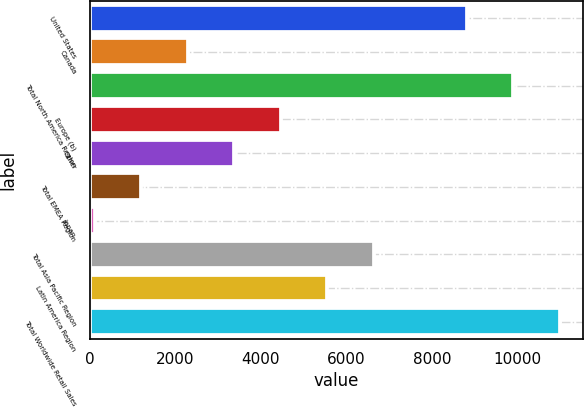<chart> <loc_0><loc_0><loc_500><loc_500><bar_chart><fcel>United States<fcel>Canada<fcel>Total North America Region<fcel>Europe (b)<fcel>Other<fcel>Total EMEA Region<fcel>Japan<fcel>Total Asia Pacific Region<fcel>Latin America Region<fcel>Total Worldwide Retail Sales<nl><fcel>8813.8<fcel>2285.2<fcel>9901.9<fcel>4461.4<fcel>3373.3<fcel>1197.1<fcel>109<fcel>6637.6<fcel>5549.5<fcel>10990<nl></chart> 